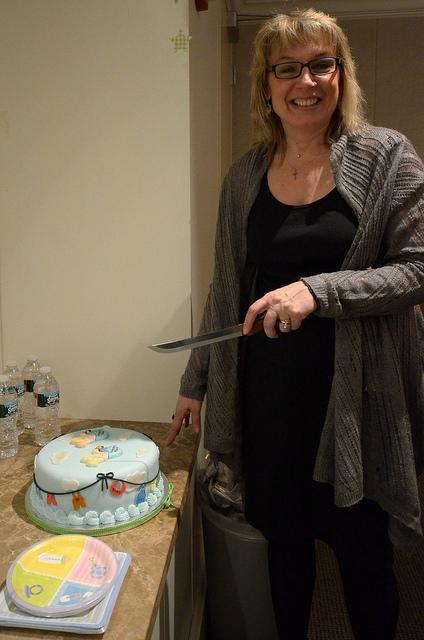How many people are cutting the cake?
Give a very brief answer. 1. How many cakes are on the table?
Give a very brief answer. 1. 